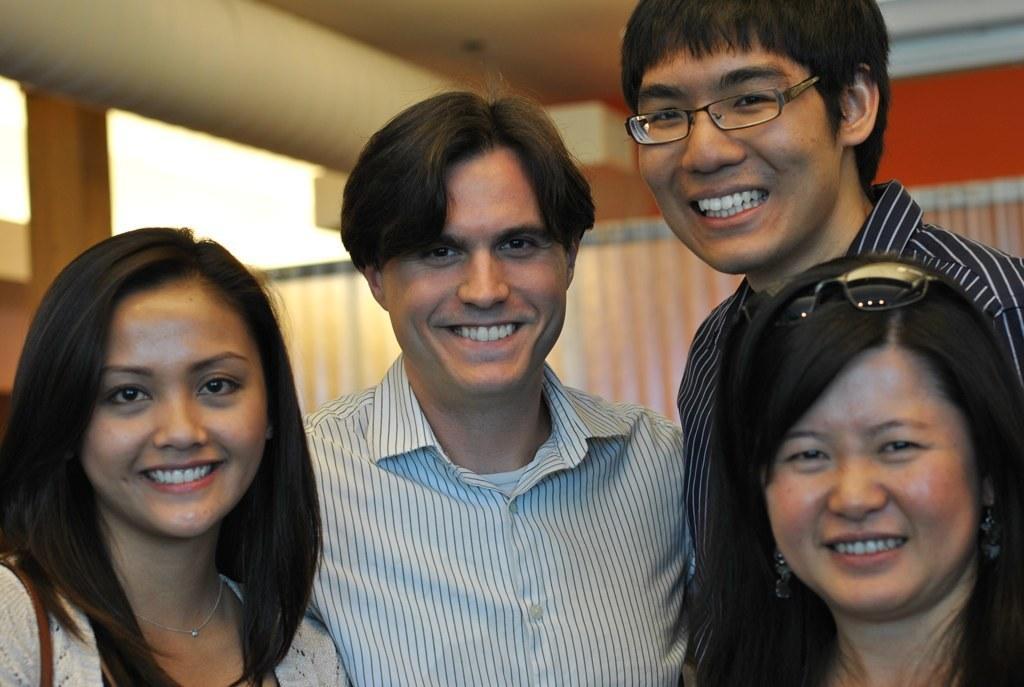Describe this image in one or two sentences. In this image in the middle, there is a man, he wears a shirt, he is smiling. On the right there is a woman, she is smiling, her hair is short behind her there is a man, he wears a shirt, he is smiling. On the left there is a woman, she wears a dress, she is smiling, her hair is short. In the background there are curtains, light and wall. 